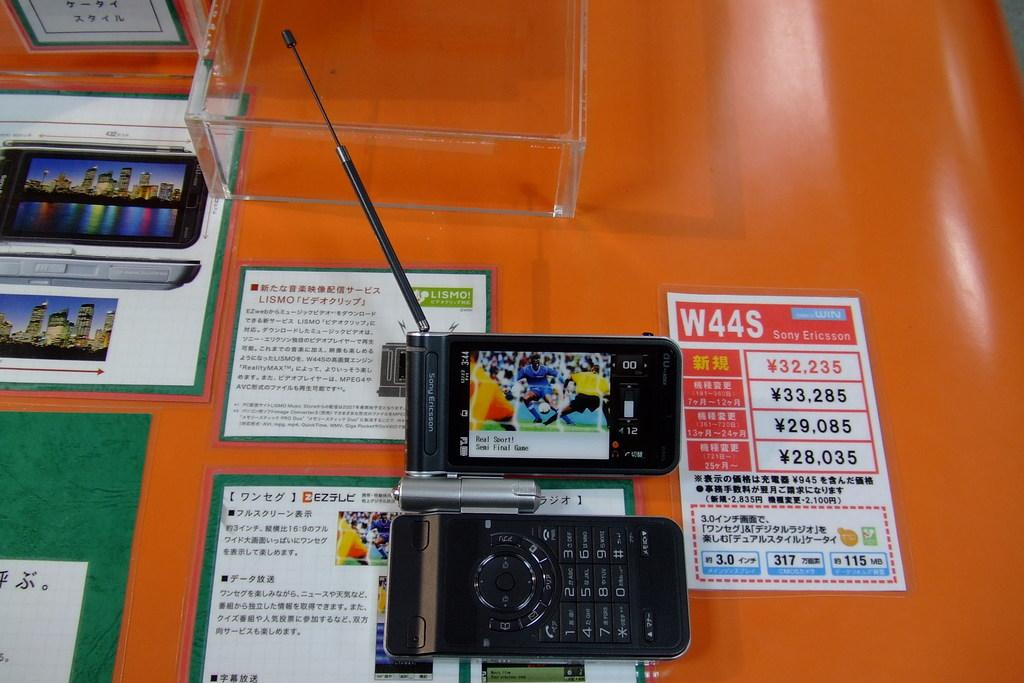<image>
Describe the image concisely. A soccer game is being shown on a Sony Ericsson cell phone device. 